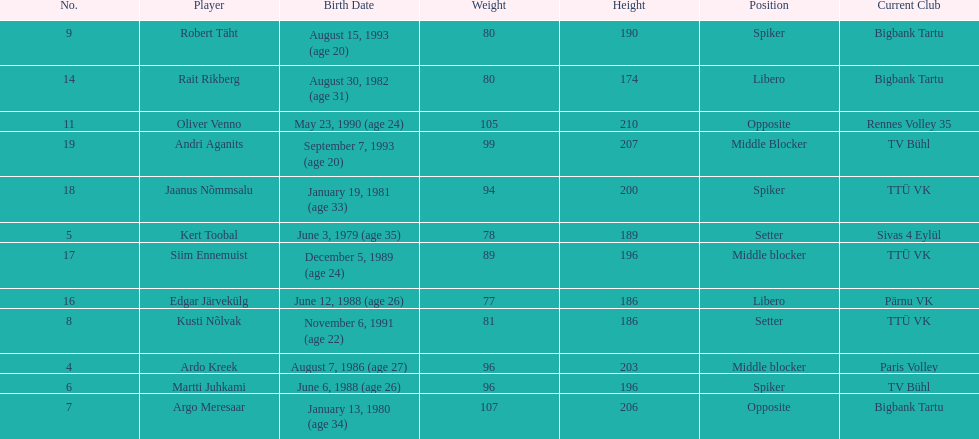How many players are middle blockers? 3. 